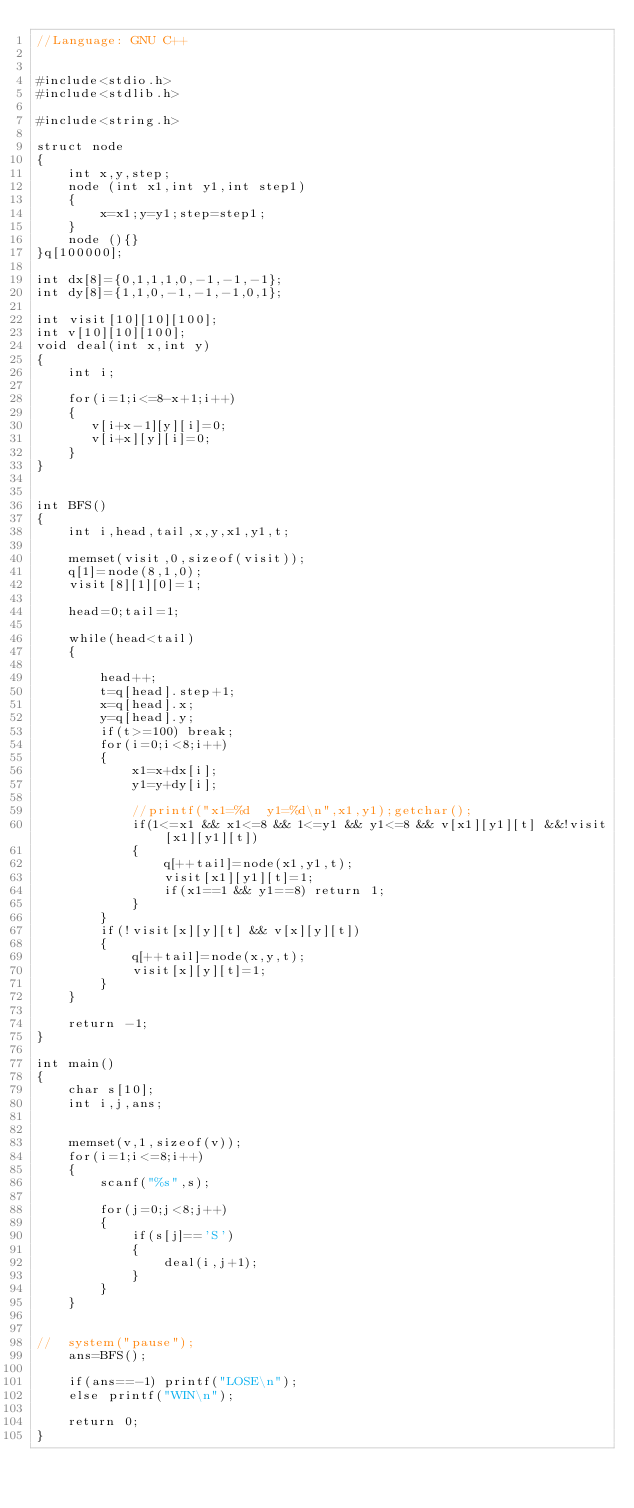Convert code to text. <code><loc_0><loc_0><loc_500><loc_500><_C++_>//Language: GNU C++


#include<stdio.h>
#include<stdlib.h>

#include<string.h>

struct node
{
	int x,y,step;
	node (int x1,int y1,int step1)
	{
		x=x1;y=y1;step=step1;
	}
	node (){}
}q[100000];

int dx[8]={0,1,1,1,0,-1,-1,-1};
int dy[8]={1,1,0,-1,-1,-1,0,1};

int visit[10][10][100];
int v[10][10][100];
void deal(int x,int y)
{
	int i;

	for(i=1;i<=8-x+1;i++)
	{
       v[i+x-1][y][i]=0;
	   v[i+x][y][i]=0;
	}
}


int BFS()
{
	int i,head,tail,x,y,x1,y1,t;

	memset(visit,0,sizeof(visit));
	q[1]=node(8,1,0);
	visit[8][1][0]=1;

	head=0;tail=1;

	while(head<tail)
	{

		head++;
		t=q[head].step+1;
		x=q[head].x;
		y=q[head].y;
        if(t>=100) break;
		for(i=0;i<8;i++)
		{
			x1=x+dx[i];
			y1=y+dy[i];

			//printf("x1=%d  y1=%d\n",x1,y1);getchar();
			if(1<=x1 && x1<=8 && 1<=y1 && y1<=8 && v[x1][y1][t] &&!visit[x1][y1][t])
			{
				q[++tail]=node(x1,y1,t);
				visit[x1][y1][t]=1;
				if(x1==1 && y1==8) return 1;
			}
		}
		if(!visit[x][y][t] && v[x][y][t])
		{
			q[++tail]=node(x,y,t);
		    visit[x][y][t]=1;
		}
	}

    return -1;
}

int main()
{
    char s[10];
	int i,j,ans;


	memset(v,1,sizeof(v));
	for(i=1;i<=8;i++)
	{
		scanf("%s",s);

		for(j=0;j<8;j++)
		{
			if(s[j]=='S')
			{
				deal(i,j+1);
			}
		}
	}


//	system("pause");
	ans=BFS();

	if(ans==-1) printf("LOSE\n");
	else printf("WIN\n");

	return 0;
}</code> 